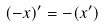<formula> <loc_0><loc_0><loc_500><loc_500>( - x ) ^ { \prime } = - ( x ^ { \prime } )</formula> 